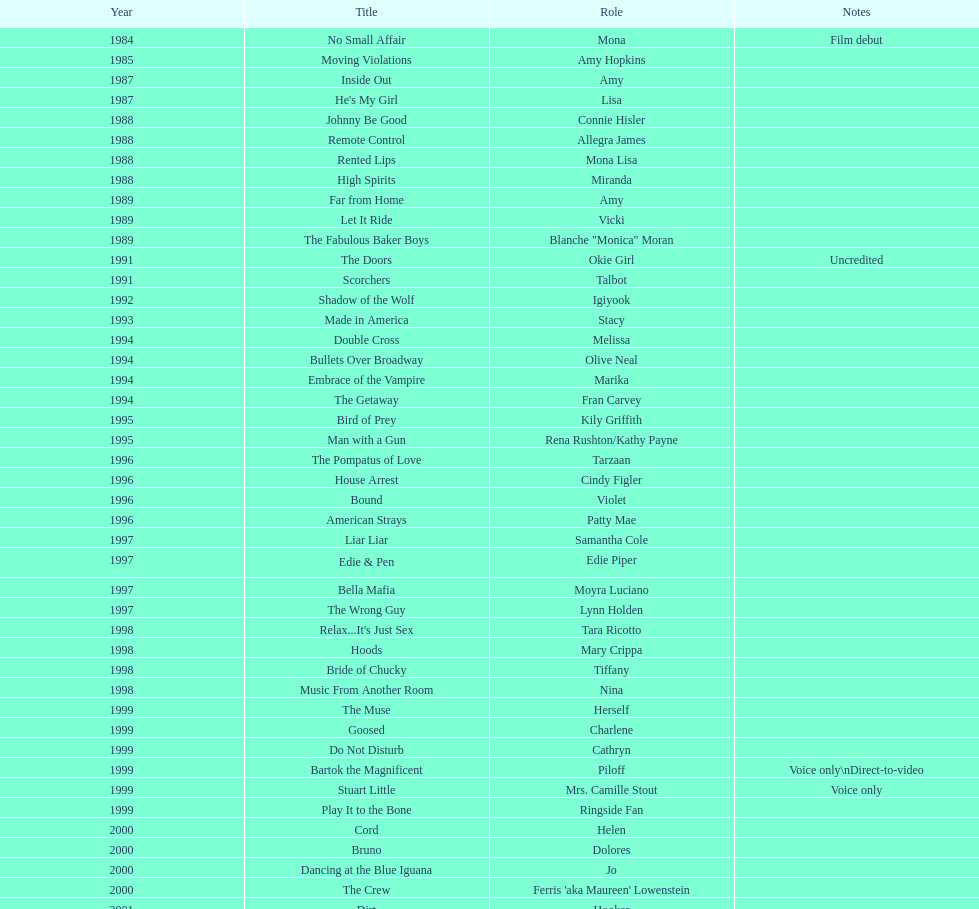In which film can one find a character with the igiyook role? Shadow of the Wolf. 